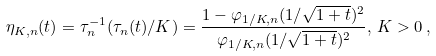Convert formula to latex. <formula><loc_0><loc_0><loc_500><loc_500>\eta _ { K , n } ( t ) = \tau _ { n } ^ { - 1 } ( \tau _ { n } ( t ) / K ) = \frac { 1 - \varphi _ { 1 / K , n } ( 1 / \sqrt { 1 + t } ) ^ { 2 } } { \varphi _ { 1 / K , n } ( 1 / \sqrt { 1 + t } ) ^ { 2 } } , \, K > 0 \, ,</formula> 